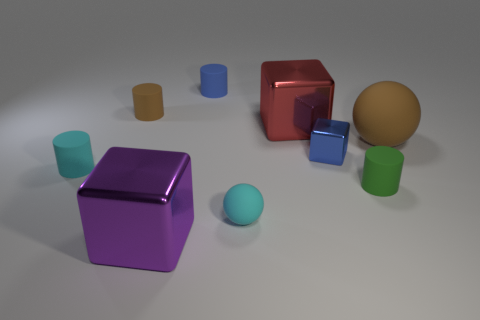Add 1 green balls. How many objects exist? 10 Subtract all balls. How many objects are left? 7 Add 4 big purple blocks. How many big purple blocks exist? 5 Subtract 1 brown balls. How many objects are left? 8 Subtract all tiny brown matte spheres. Subtract all big brown matte things. How many objects are left? 8 Add 1 small brown objects. How many small brown objects are left? 2 